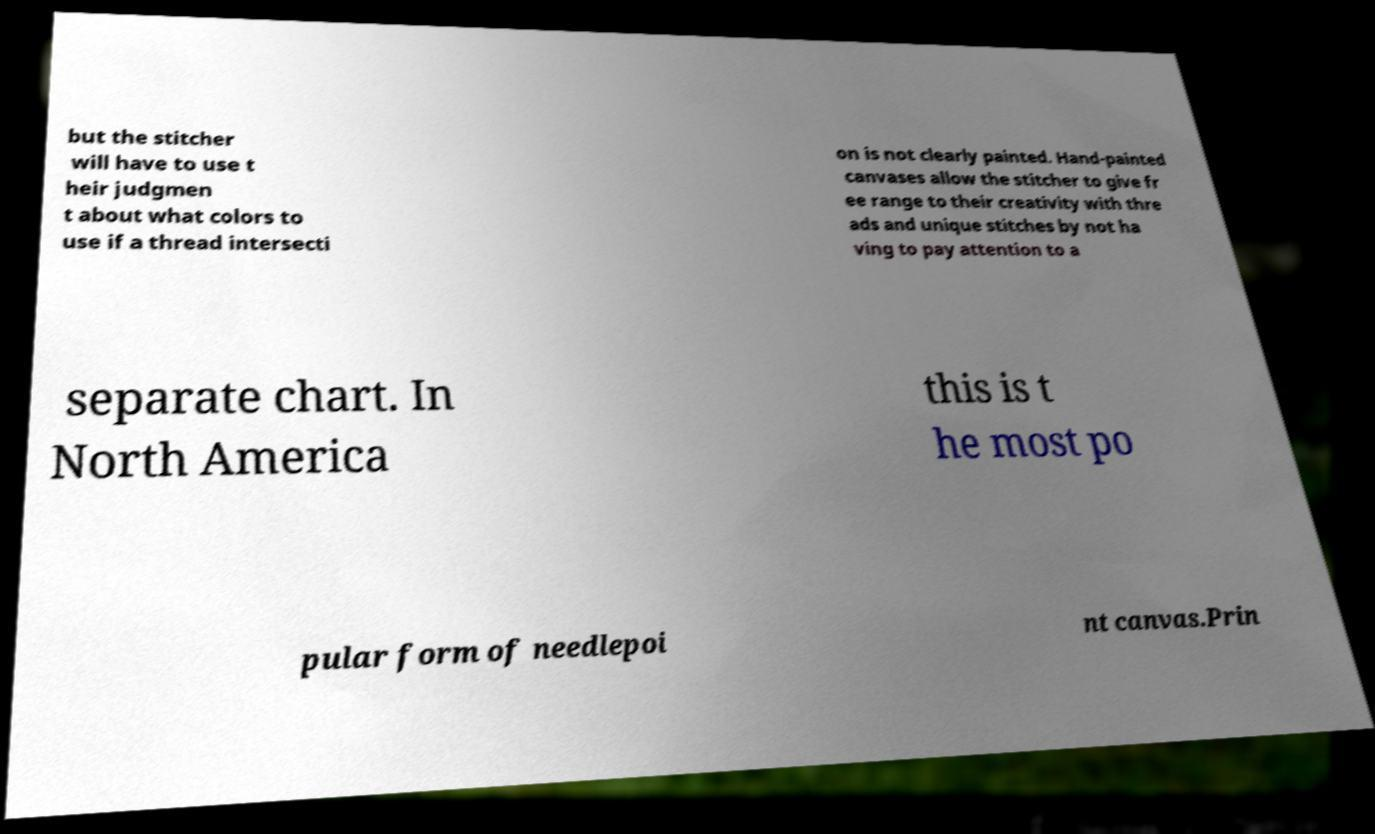Could you assist in decoding the text presented in this image and type it out clearly? but the stitcher will have to use t heir judgmen t about what colors to use if a thread intersecti on is not clearly painted. Hand-painted canvases allow the stitcher to give fr ee range to their creativity with thre ads and unique stitches by not ha ving to pay attention to a separate chart. In North America this is t he most po pular form of needlepoi nt canvas.Prin 